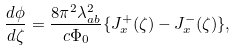Convert formula to latex. <formula><loc_0><loc_0><loc_500><loc_500>\frac { d \phi } { d \zeta } = \frac { 8 \pi ^ { 2 } \lambda _ { a b } ^ { 2 } } { c \Phi _ { 0 } } \{ J _ { x } ^ { + } ( \zeta ) - J _ { x } ^ { - } ( \zeta ) \} ,</formula> 